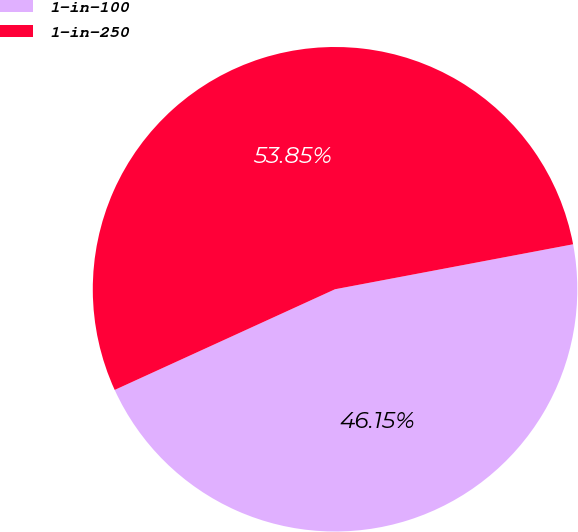Convert chart. <chart><loc_0><loc_0><loc_500><loc_500><pie_chart><fcel>1-in-100<fcel>1-in-250<nl><fcel>46.15%<fcel>53.85%<nl></chart> 